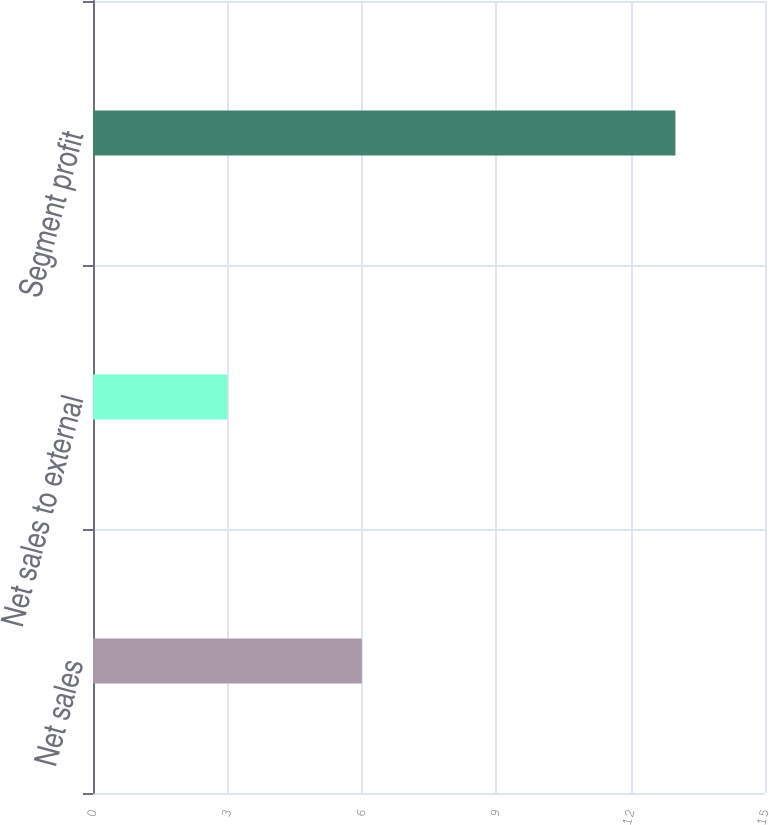<chart> <loc_0><loc_0><loc_500><loc_500><bar_chart><fcel>Net sales<fcel>Net sales to external<fcel>Segment profit<nl><fcel>6<fcel>3<fcel>13<nl></chart> 